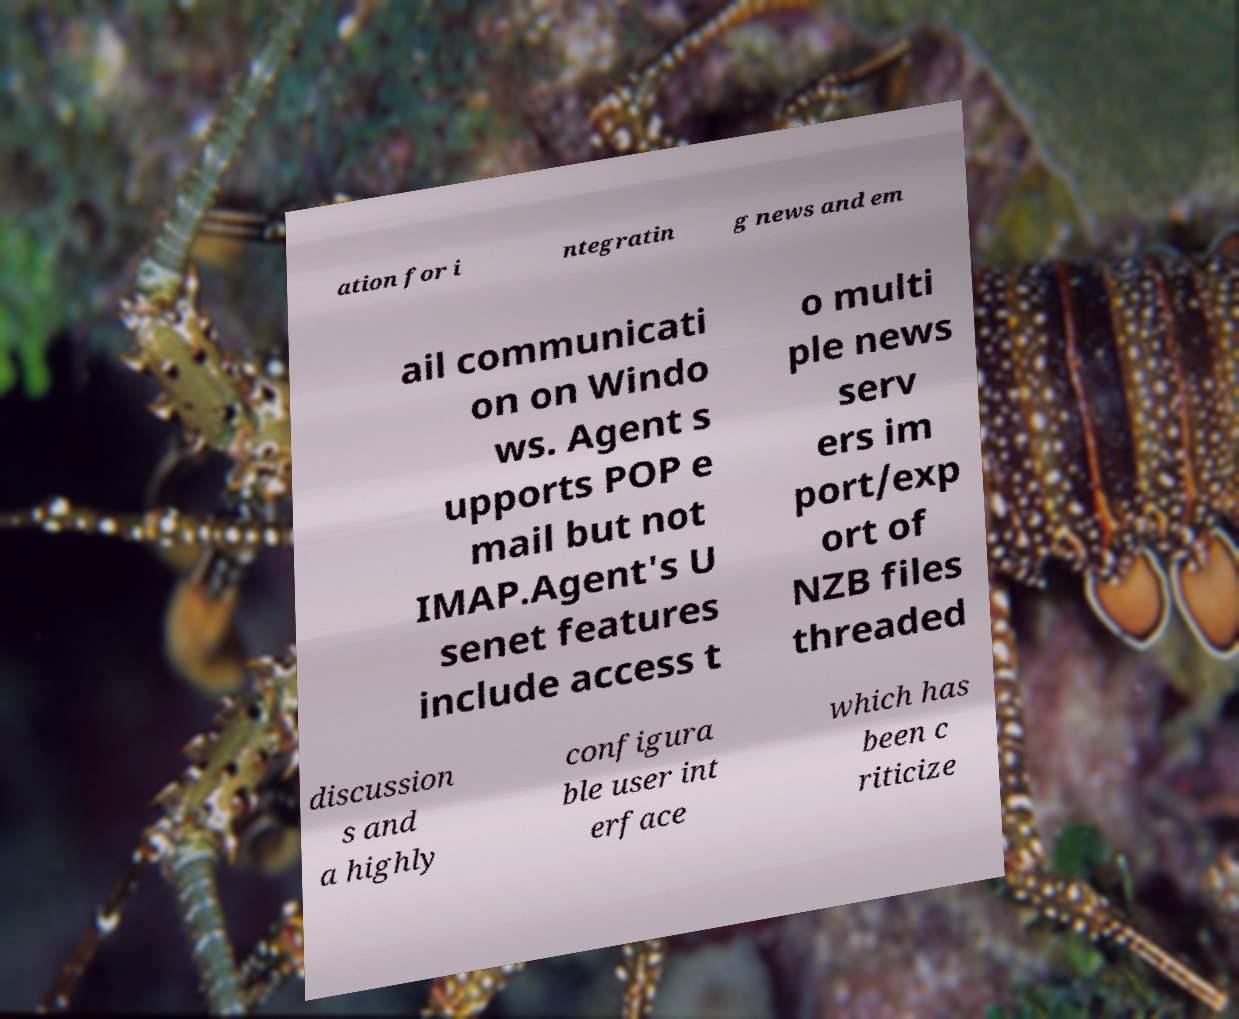Can you read and provide the text displayed in the image?This photo seems to have some interesting text. Can you extract and type it out for me? ation for i ntegratin g news and em ail communicati on on Windo ws. Agent s upports POP e mail but not IMAP.Agent's U senet features include access t o multi ple news serv ers im port/exp ort of NZB files threaded discussion s and a highly configura ble user int erface which has been c riticize 